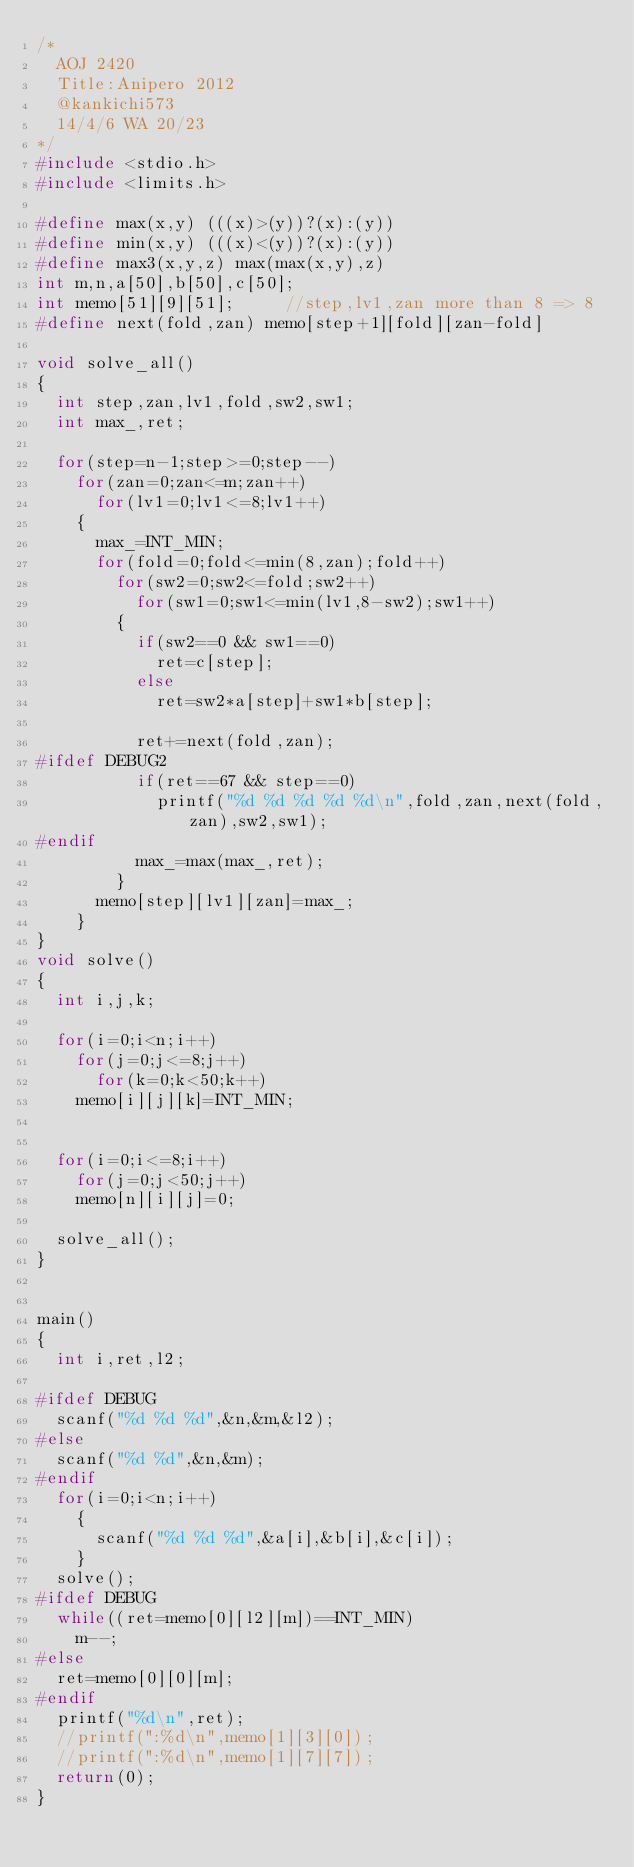Convert code to text. <code><loc_0><loc_0><loc_500><loc_500><_C_>/*
  AOJ 2420
  Title:Anipero 2012
  @kankichi573
  14/4/6 WA 20/23
*/
#include <stdio.h>
#include <limits.h>

#define max(x,y) (((x)>(y))?(x):(y))
#define min(x,y) (((x)<(y))?(x):(y))
#define max3(x,y,z) max(max(x,y),z)
int m,n,a[50],b[50],c[50];
int memo[51][9][51];     //step,lv1,zan more than 8 => 8
#define next(fold,zan) memo[step+1][fold][zan-fold]

void solve_all()
{
  int step,zan,lv1,fold,sw2,sw1;
  int max_,ret;
  
  for(step=n-1;step>=0;step--)
    for(zan=0;zan<=m;zan++)
      for(lv1=0;lv1<=8;lv1++)
	{
	  max_=INT_MIN;
	  for(fold=0;fold<=min(8,zan);fold++)
	    for(sw2=0;sw2<=fold;sw2++)
	      for(sw1=0;sw1<=min(lv1,8-sw2);sw1++)
		{
		  if(sw2==0 && sw1==0)
		    ret=c[step];
		  else
		    ret=sw2*a[step]+sw1*b[step];

		  ret+=next(fold,zan);
#ifdef DEBUG2		  
		  if(ret==67 && step==0) 
		    printf("%d %d %d %d %d\n",fold,zan,next(fold,zan),sw2,sw1);
#endif		  
		  max_=max(max_,ret);
		}
	  memo[step][lv1][zan]=max_;
	}
}
void solve()
{
  int i,j,k;

  for(i=0;i<n;i++)
    for(j=0;j<=8;j++)
      for(k=0;k<50;k++)
	memo[i][j][k]=INT_MIN;


  for(i=0;i<=8;i++)
    for(j=0;j<50;j++)
	memo[n][i][j]=0;

  solve_all();
}


main()
{
  int i,ret,l2;

#ifdef DEBUG
  scanf("%d %d %d",&n,&m,&l2);
#else
  scanf("%d %d",&n,&m);
#endif
  for(i=0;i<n;i++)
    {
      scanf("%d %d %d",&a[i],&b[i],&c[i]);
    }
  solve();
#ifdef DEBUG
  while((ret=memo[0][l2][m])==INT_MIN)
    m--;
#else
  ret=memo[0][0][m];
#endif
  printf("%d\n",ret);
  //printf(":%d\n",memo[1][3][0]);
  //printf(":%d\n",memo[1][7][7]);
  return(0);
}</code> 